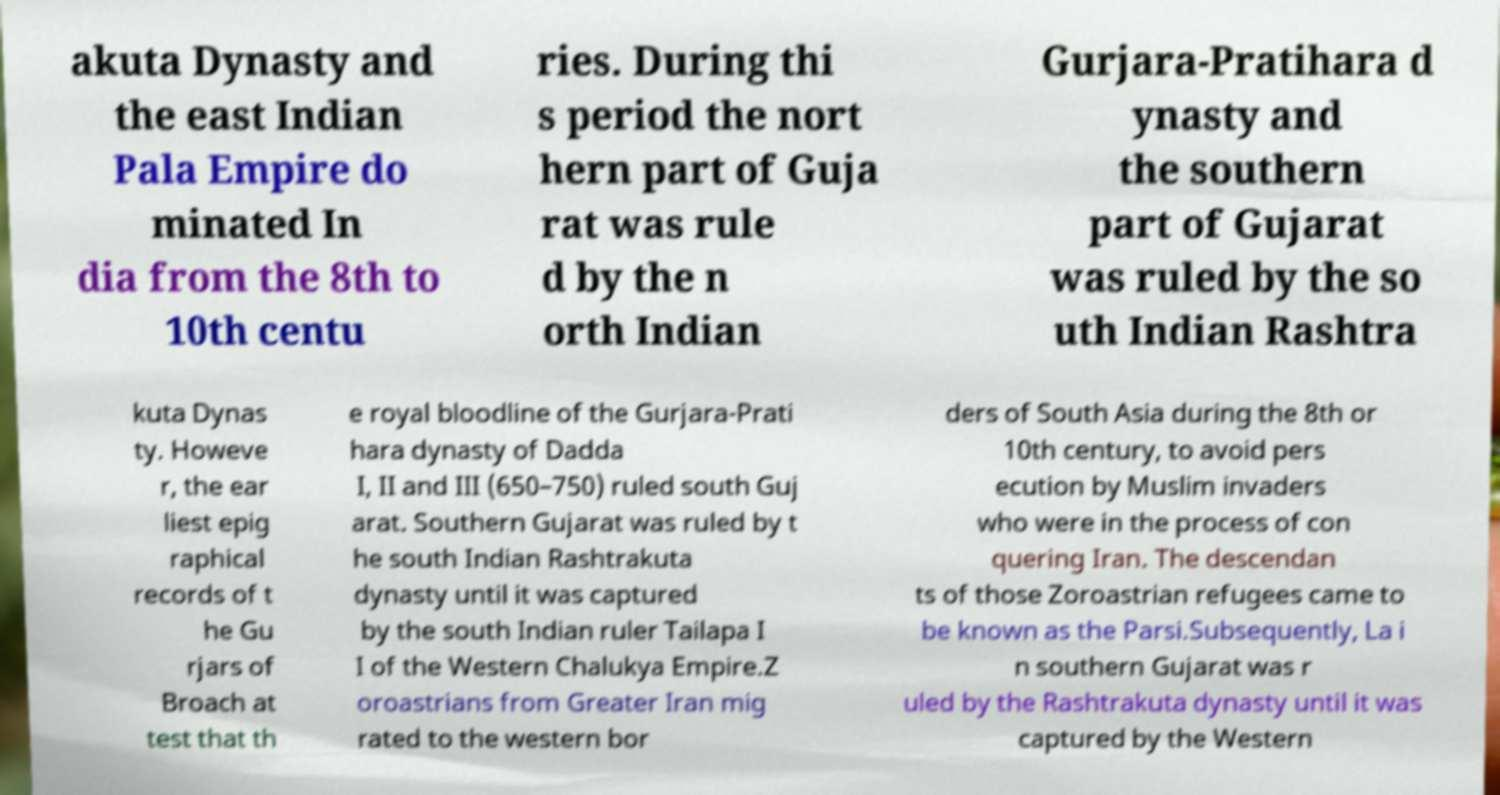Can you accurately transcribe the text from the provided image for me? akuta Dynasty and the east Indian Pala Empire do minated In dia from the 8th to 10th centu ries. During thi s period the nort hern part of Guja rat was rule d by the n orth Indian Gurjara-Pratihara d ynasty and the southern part of Gujarat was ruled by the so uth Indian Rashtra kuta Dynas ty. Howeve r, the ear liest epig raphical records of t he Gu rjars of Broach at test that th e royal bloodline of the Gurjara-Prati hara dynasty of Dadda I, II and III (650–750) ruled south Guj arat. Southern Gujarat was ruled by t he south Indian Rashtrakuta dynasty until it was captured by the south Indian ruler Tailapa I I of the Western Chalukya Empire.Z oroastrians from Greater Iran mig rated to the western bor ders of South Asia during the 8th or 10th century, to avoid pers ecution by Muslim invaders who were in the process of con quering Iran. The descendan ts of those Zoroastrian refugees came to be known as the Parsi.Subsequently, La i n southern Gujarat was r uled by the Rashtrakuta dynasty until it was captured by the Western 